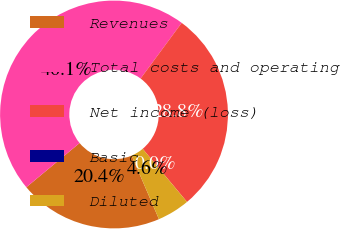Convert chart. <chart><loc_0><loc_0><loc_500><loc_500><pie_chart><fcel>Revenues<fcel>Total costs and operating<fcel>Net income (loss)<fcel>Basic<fcel>Diluted<nl><fcel>20.43%<fcel>46.15%<fcel>28.8%<fcel>0.0%<fcel>4.62%<nl></chart> 